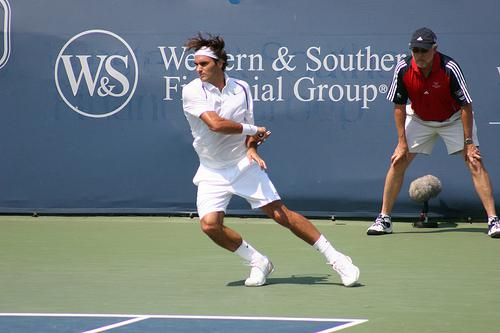Question: where was this picture taken?
Choices:
A. A football field.
B. A tennis court.
C. A baseball field.
D. A sports arena.
Answer with the letter. Answer: B Question: who is in the picture?
Choices:
A. Two people.
B. Two men.
C. A man and a woman.
D. A tennis player and a man.
Answer with the letter. Answer: D Question: who is wearing a hat?
Choices:
A. The guy in the front.
B. A woman in the back.
C. The man in the back.
D. A child.
Answer with the letter. Answer: C 